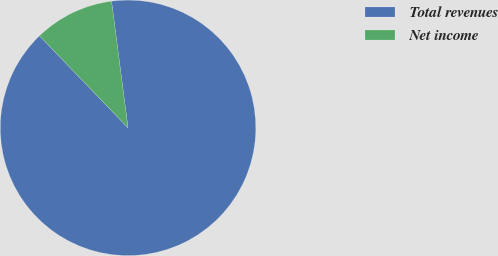<chart> <loc_0><loc_0><loc_500><loc_500><pie_chart><fcel>Total revenues<fcel>Net income<nl><fcel>89.87%<fcel>10.13%<nl></chart> 